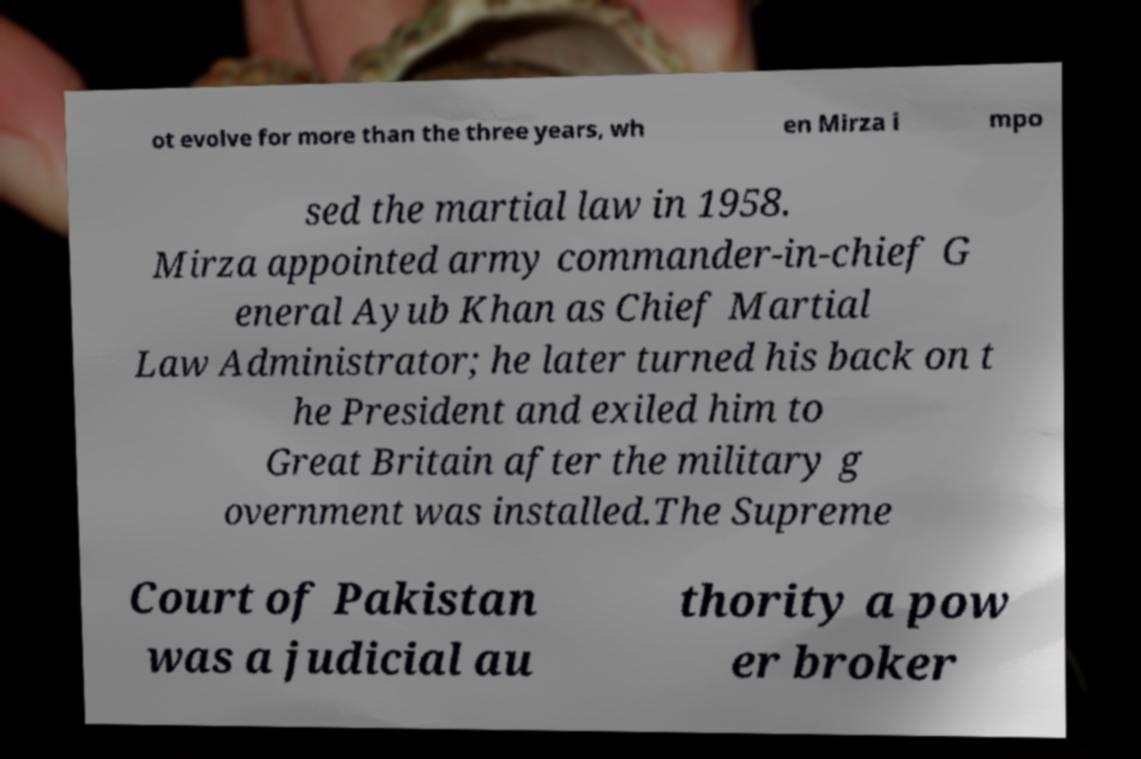I need the written content from this picture converted into text. Can you do that? ot evolve for more than the three years, wh en Mirza i mpo sed the martial law in 1958. Mirza appointed army commander-in-chief G eneral Ayub Khan as Chief Martial Law Administrator; he later turned his back on t he President and exiled him to Great Britain after the military g overnment was installed.The Supreme Court of Pakistan was a judicial au thority a pow er broker 